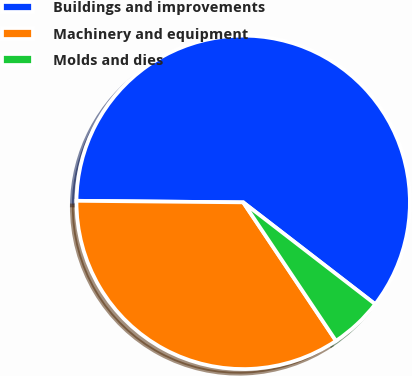Convert chart. <chart><loc_0><loc_0><loc_500><loc_500><pie_chart><fcel>Buildings and improvements<fcel>Machinery and equipment<fcel>Molds and dies<nl><fcel>60.31%<fcel>34.54%<fcel>5.15%<nl></chart> 